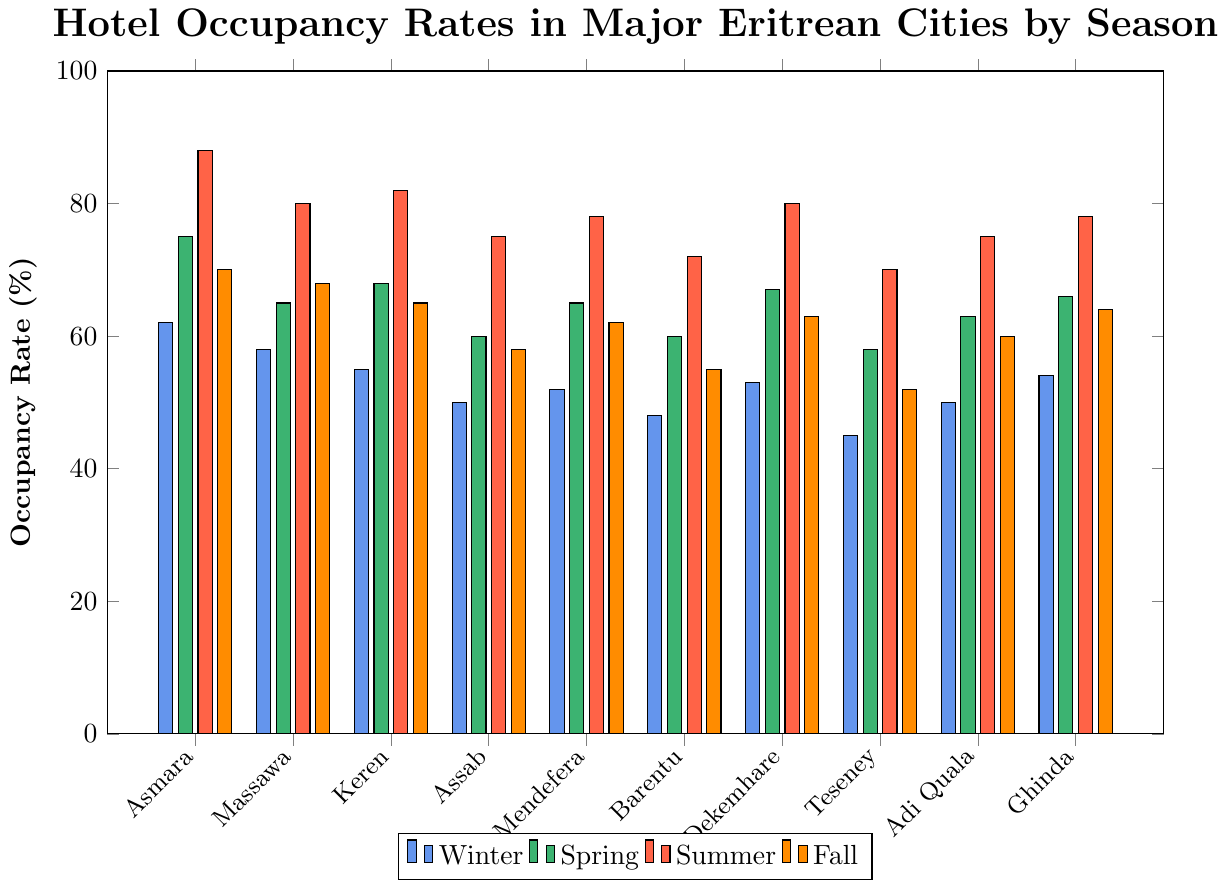What's the city with the highest hotel occupancy rate in the summer? To determine the city with the highest occupancy rate in summer, compare the height of the red bars for each city. Asmara has the highest bar.
Answer: Asmara Which season has the lowest average occupancy rate across all cities? Calculate the average occupancy rate for each season by summing the rates of all cities for each season and dividing by the number of cities (10). Winter: (62+58+55+50+52+48+53+45+50+54)/10 = 52.7; Spring: (75+65+68+60+65+60+67+58+63+66)/10 = 64.7; Summer: (88+80+82+75+78+72+80+70+75+78)/10 = 77.8; Fall: (70+68+65+58+62+55+63+52+60+64)/10 = 61.7. Winter has the lowest average.
Answer: Winter What is the occupancy rate difference between Asmara and Teseney in winter? Subtract Teseney's winter occupancy rate from Asmara's: 62 - 45.
Answer: 17 In which city is the change in occupancy rate from winter to summer the smallest? Calculate the difference between the winter and summer rates for each city. The changes are: Asmara: 88-62=26, Massawa: 80-58=22, Keren: 82-55=27, Assab: 75-50=25, Mendefera: 78-52=26, Barentu: 72-48=24, Dekemhare: 80-53=27, Teseney: 70-45=25, Adi Quala: 75-50=25, Ghinda: 78-54=24. Massawa has the smallest change.
Answer: Massawa Which city had the highest occupancy rate in Spring? Observe the highest bar in green. Asmara has the highest green bar.
Answer: Asmara What is the average occupancy rate in Keren across all seasons? Sum Keren's occupancy rates for all seasons and divide by 4: (55+68+82+65)/4 = 67.5.
Answer: 67.5 Between Massawa and Mendefera, which has a higher fall occupancy rate? Compare the heights of the orange bars for Massawa and Mendefera. Massawa has a higher bar.
Answer: Massawa Which city has the most consistent occupancy rate across all seasons? Determine the city with the smallest range (max rate - min rate). Calculate: Asmara: 88-62=26, Massawa: 80-58=22, Keren: 82-55=27, Assab: 75-50=25, Mendefera: 78-52=26, Barentu: 72-48=24, Dekemhare: 80-53=27, Teseney: 70-45=25, Adi Quala: 75-50=25, Ghinda: 78-54=24. Massawa has the smallest range.
Answer: Massawa Which city shows the maximum increase in occupancy rate from spring to summer? Calculate the increase for each city: Asmara: 88-75=13, Massawa: 80-65=15, Keren: 82-68=14, Assab: 75-60=15, Mendefera: 78-65=13, Barentu: 72-60=12, Dekemhare: 80-67=13, Teseney: 70-58=12, Adi Quala: 75-63=12, Ghinda: 78-66=12. Massawa and Assab have the highest increase, tied at 15%.
Answer: Massawa and Assab 